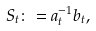Convert formula to latex. <formula><loc_0><loc_0><loc_500><loc_500>S _ { t } \colon = a _ { t } ^ { - 1 } b _ { t } ,</formula> 